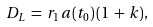<formula> <loc_0><loc_0><loc_500><loc_500>D _ { L } \, = \, r _ { 1 } \, a ( t _ { 0 } ) \, ( 1 \, + \, k ) ,</formula> 